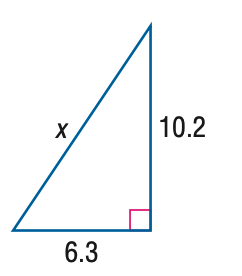Answer the mathemtical geometry problem and directly provide the correct option letter.
Question: Find x.
Choices: A: 11.0 B: 11.5 C: 12.0 D: 12.5 C 